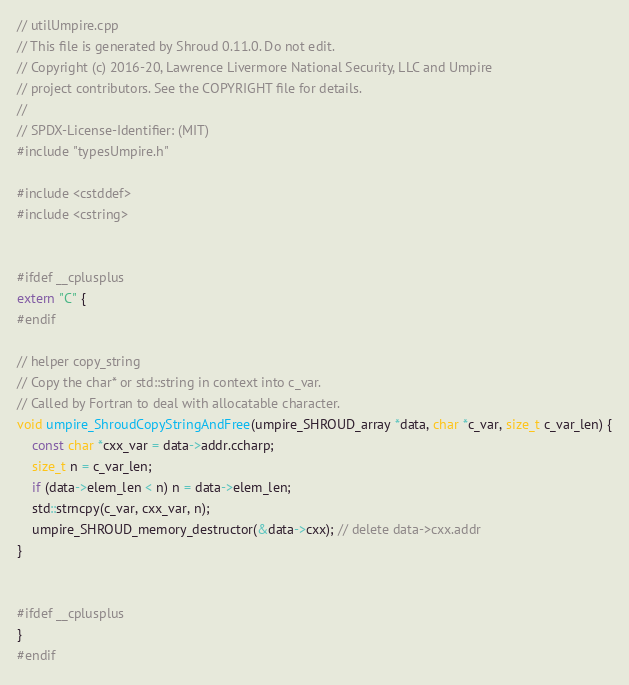Convert code to text. <code><loc_0><loc_0><loc_500><loc_500><_C++_>// utilUmpire.cpp
// This file is generated by Shroud 0.11.0. Do not edit.
// Copyright (c) 2016-20, Lawrence Livermore National Security, LLC and Umpire
// project contributors. See the COPYRIGHT file for details.
//
// SPDX-License-Identifier: (MIT)
#include "typesUmpire.h"

#include <cstddef>
#include <cstring>


#ifdef __cplusplus
extern "C" {
#endif

// helper copy_string
// Copy the char* or std::string in context into c_var.
// Called by Fortran to deal with allocatable character.
void umpire_ShroudCopyStringAndFree(umpire_SHROUD_array *data, char *c_var, size_t c_var_len) {
    const char *cxx_var = data->addr.ccharp;
    size_t n = c_var_len;
    if (data->elem_len < n) n = data->elem_len;
    std::strncpy(c_var, cxx_var, n);
    umpire_SHROUD_memory_destructor(&data->cxx); // delete data->cxx.addr
}


#ifdef __cplusplus
}
#endif
</code> 